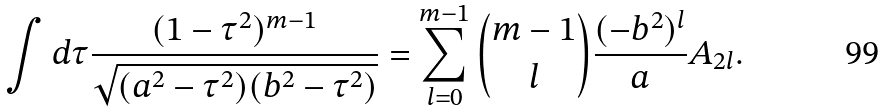Convert formula to latex. <formula><loc_0><loc_0><loc_500><loc_500>\int d \tau \frac { ( 1 - \tau ^ { 2 } ) ^ { m - 1 } } { \sqrt { ( a ^ { 2 } - \tau ^ { 2 } ) ( b ^ { 2 } - \tau ^ { 2 } ) } } = \sum _ { l = 0 } ^ { m - 1 } \binom { m - 1 } { l } \frac { ( - b ^ { 2 } ) ^ { l } } { a } A _ { 2 l } .</formula> 